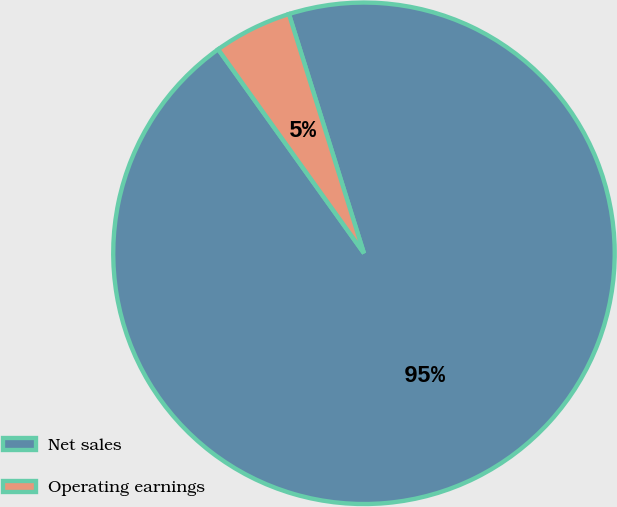Convert chart to OTSL. <chart><loc_0><loc_0><loc_500><loc_500><pie_chart><fcel>Net sales<fcel>Operating earnings<nl><fcel>94.96%<fcel>5.04%<nl></chart> 